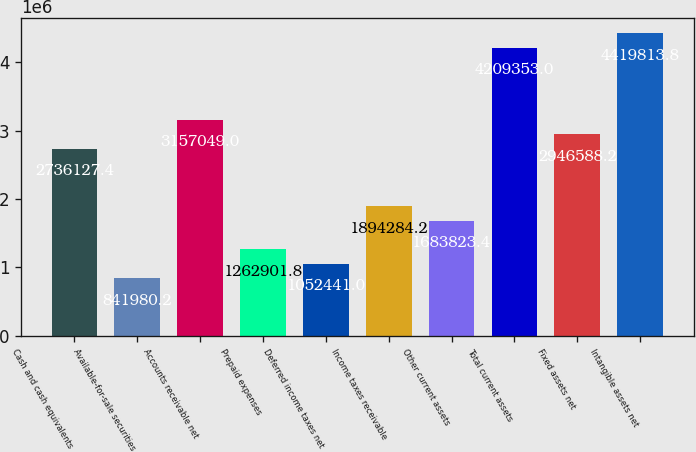Convert chart. <chart><loc_0><loc_0><loc_500><loc_500><bar_chart><fcel>Cash and cash equivalents<fcel>Available-for-sale securities<fcel>Accounts receivable net<fcel>Prepaid expenses<fcel>Deferred income taxes net<fcel>Income taxes receivable<fcel>Other current assets<fcel>Total current assets<fcel>Fixed assets net<fcel>Intangible assets net<nl><fcel>2.73613e+06<fcel>841980<fcel>3.15705e+06<fcel>1.2629e+06<fcel>1.05244e+06<fcel>1.89428e+06<fcel>1.68382e+06<fcel>4.20935e+06<fcel>2.94659e+06<fcel>4.41981e+06<nl></chart> 